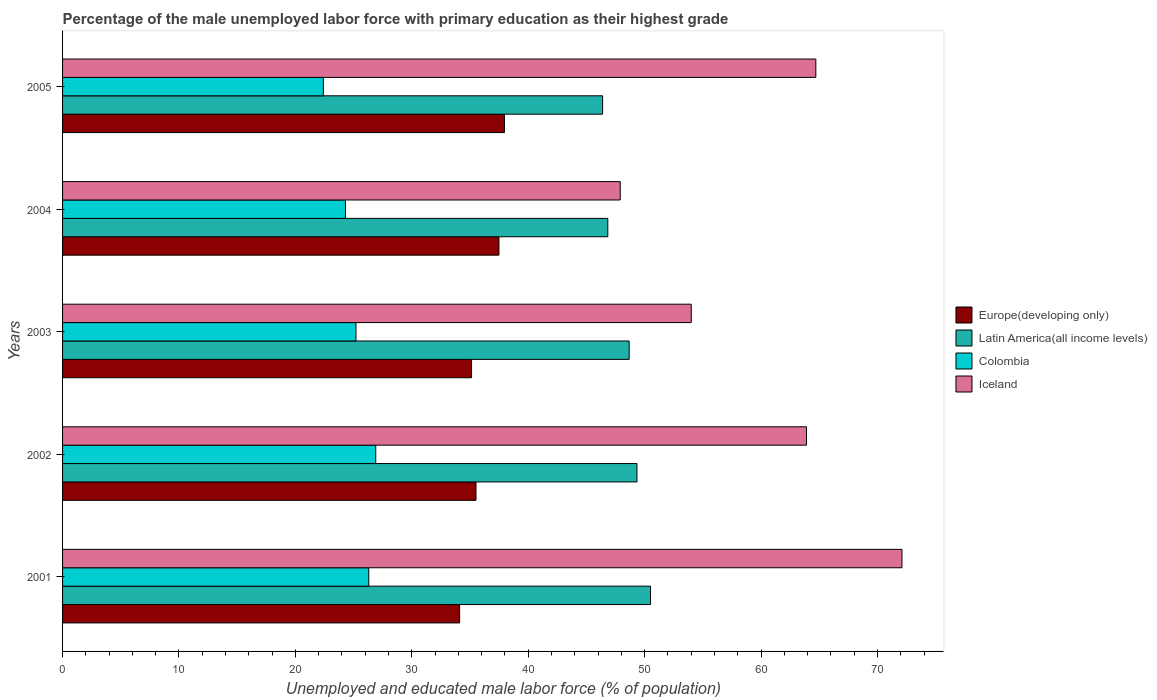Are the number of bars on each tick of the Y-axis equal?
Your response must be concise. Yes. How many bars are there on the 3rd tick from the bottom?
Provide a succinct answer. 4. What is the label of the 5th group of bars from the top?
Provide a short and direct response. 2001. What is the percentage of the unemployed male labor force with primary education in Iceland in 2002?
Ensure brevity in your answer.  63.9. Across all years, what is the maximum percentage of the unemployed male labor force with primary education in Latin America(all income levels)?
Your answer should be very brief. 50.5. Across all years, what is the minimum percentage of the unemployed male labor force with primary education in Latin America(all income levels)?
Offer a terse response. 46.39. In which year was the percentage of the unemployed male labor force with primary education in Colombia maximum?
Your answer should be very brief. 2002. In which year was the percentage of the unemployed male labor force with primary education in Iceland minimum?
Offer a very short reply. 2004. What is the total percentage of the unemployed male labor force with primary education in Iceland in the graph?
Make the answer very short. 302.6. What is the difference between the percentage of the unemployed male labor force with primary education in Iceland in 2001 and that in 2004?
Offer a very short reply. 24.2. What is the difference between the percentage of the unemployed male labor force with primary education in Latin America(all income levels) in 2003 and the percentage of the unemployed male labor force with primary education in Europe(developing only) in 2002?
Ensure brevity in your answer.  13.16. What is the average percentage of the unemployed male labor force with primary education in Colombia per year?
Offer a very short reply. 25.02. In the year 2001, what is the difference between the percentage of the unemployed male labor force with primary education in Latin America(all income levels) and percentage of the unemployed male labor force with primary education in Colombia?
Keep it short and to the point. 24.2. What is the ratio of the percentage of the unemployed male labor force with primary education in Colombia in 2002 to that in 2004?
Your answer should be very brief. 1.11. Is the difference between the percentage of the unemployed male labor force with primary education in Latin America(all income levels) in 2003 and 2005 greater than the difference between the percentage of the unemployed male labor force with primary education in Colombia in 2003 and 2005?
Your response must be concise. No. What is the difference between the highest and the second highest percentage of the unemployed male labor force with primary education in Iceland?
Provide a short and direct response. 7.4. What is the difference between the highest and the lowest percentage of the unemployed male labor force with primary education in Colombia?
Give a very brief answer. 4.5. In how many years, is the percentage of the unemployed male labor force with primary education in Iceland greater than the average percentage of the unemployed male labor force with primary education in Iceland taken over all years?
Make the answer very short. 3. What does the 2nd bar from the bottom in 2003 represents?
Provide a short and direct response. Latin America(all income levels). Is it the case that in every year, the sum of the percentage of the unemployed male labor force with primary education in Iceland and percentage of the unemployed male labor force with primary education in Colombia is greater than the percentage of the unemployed male labor force with primary education in Europe(developing only)?
Keep it short and to the point. Yes. Are the values on the major ticks of X-axis written in scientific E-notation?
Make the answer very short. No. Where does the legend appear in the graph?
Your response must be concise. Center right. How many legend labels are there?
Provide a short and direct response. 4. How are the legend labels stacked?
Make the answer very short. Vertical. What is the title of the graph?
Your answer should be compact. Percentage of the male unemployed labor force with primary education as their highest grade. What is the label or title of the X-axis?
Make the answer very short. Unemployed and educated male labor force (% of population). What is the Unemployed and educated male labor force (% of population) in Europe(developing only) in 2001?
Provide a short and direct response. 34.1. What is the Unemployed and educated male labor force (% of population) in Latin America(all income levels) in 2001?
Your answer should be very brief. 50.5. What is the Unemployed and educated male labor force (% of population) in Colombia in 2001?
Ensure brevity in your answer.  26.3. What is the Unemployed and educated male labor force (% of population) in Iceland in 2001?
Make the answer very short. 72.1. What is the Unemployed and educated male labor force (% of population) in Europe(developing only) in 2002?
Offer a terse response. 35.51. What is the Unemployed and educated male labor force (% of population) in Latin America(all income levels) in 2002?
Give a very brief answer. 49.34. What is the Unemployed and educated male labor force (% of population) in Colombia in 2002?
Provide a short and direct response. 26.9. What is the Unemployed and educated male labor force (% of population) in Iceland in 2002?
Make the answer very short. 63.9. What is the Unemployed and educated male labor force (% of population) in Europe(developing only) in 2003?
Ensure brevity in your answer.  35.13. What is the Unemployed and educated male labor force (% of population) in Latin America(all income levels) in 2003?
Offer a very short reply. 48.67. What is the Unemployed and educated male labor force (% of population) in Colombia in 2003?
Offer a terse response. 25.2. What is the Unemployed and educated male labor force (% of population) of Iceland in 2003?
Your answer should be very brief. 54. What is the Unemployed and educated male labor force (% of population) in Europe(developing only) in 2004?
Offer a terse response. 37.48. What is the Unemployed and educated male labor force (% of population) in Latin America(all income levels) in 2004?
Your response must be concise. 46.83. What is the Unemployed and educated male labor force (% of population) of Colombia in 2004?
Give a very brief answer. 24.3. What is the Unemployed and educated male labor force (% of population) in Iceland in 2004?
Offer a terse response. 47.9. What is the Unemployed and educated male labor force (% of population) in Europe(developing only) in 2005?
Your response must be concise. 37.96. What is the Unemployed and educated male labor force (% of population) of Latin America(all income levels) in 2005?
Ensure brevity in your answer.  46.39. What is the Unemployed and educated male labor force (% of population) in Colombia in 2005?
Ensure brevity in your answer.  22.4. What is the Unemployed and educated male labor force (% of population) in Iceland in 2005?
Give a very brief answer. 64.7. Across all years, what is the maximum Unemployed and educated male labor force (% of population) in Europe(developing only)?
Provide a succinct answer. 37.96. Across all years, what is the maximum Unemployed and educated male labor force (% of population) in Latin America(all income levels)?
Offer a very short reply. 50.5. Across all years, what is the maximum Unemployed and educated male labor force (% of population) of Colombia?
Provide a short and direct response. 26.9. Across all years, what is the maximum Unemployed and educated male labor force (% of population) of Iceland?
Keep it short and to the point. 72.1. Across all years, what is the minimum Unemployed and educated male labor force (% of population) in Europe(developing only)?
Offer a terse response. 34.1. Across all years, what is the minimum Unemployed and educated male labor force (% of population) in Latin America(all income levels)?
Ensure brevity in your answer.  46.39. Across all years, what is the minimum Unemployed and educated male labor force (% of population) of Colombia?
Offer a terse response. 22.4. Across all years, what is the minimum Unemployed and educated male labor force (% of population) of Iceland?
Make the answer very short. 47.9. What is the total Unemployed and educated male labor force (% of population) of Europe(developing only) in the graph?
Your answer should be compact. 180.18. What is the total Unemployed and educated male labor force (% of population) in Latin America(all income levels) in the graph?
Give a very brief answer. 241.73. What is the total Unemployed and educated male labor force (% of population) in Colombia in the graph?
Offer a terse response. 125.1. What is the total Unemployed and educated male labor force (% of population) in Iceland in the graph?
Keep it short and to the point. 302.6. What is the difference between the Unemployed and educated male labor force (% of population) in Europe(developing only) in 2001 and that in 2002?
Provide a succinct answer. -1.41. What is the difference between the Unemployed and educated male labor force (% of population) of Latin America(all income levels) in 2001 and that in 2002?
Your answer should be very brief. 1.16. What is the difference between the Unemployed and educated male labor force (% of population) of Colombia in 2001 and that in 2002?
Keep it short and to the point. -0.6. What is the difference between the Unemployed and educated male labor force (% of population) in Europe(developing only) in 2001 and that in 2003?
Your response must be concise. -1.03. What is the difference between the Unemployed and educated male labor force (% of population) of Latin America(all income levels) in 2001 and that in 2003?
Give a very brief answer. 1.83. What is the difference between the Unemployed and educated male labor force (% of population) of Colombia in 2001 and that in 2003?
Offer a terse response. 1.1. What is the difference between the Unemployed and educated male labor force (% of population) of Europe(developing only) in 2001 and that in 2004?
Provide a short and direct response. -3.38. What is the difference between the Unemployed and educated male labor force (% of population) in Latin America(all income levels) in 2001 and that in 2004?
Keep it short and to the point. 3.67. What is the difference between the Unemployed and educated male labor force (% of population) of Iceland in 2001 and that in 2004?
Give a very brief answer. 24.2. What is the difference between the Unemployed and educated male labor force (% of population) in Europe(developing only) in 2001 and that in 2005?
Give a very brief answer. -3.85. What is the difference between the Unemployed and educated male labor force (% of population) in Latin America(all income levels) in 2001 and that in 2005?
Keep it short and to the point. 4.12. What is the difference between the Unemployed and educated male labor force (% of population) in Iceland in 2001 and that in 2005?
Give a very brief answer. 7.4. What is the difference between the Unemployed and educated male labor force (% of population) of Europe(developing only) in 2002 and that in 2003?
Provide a succinct answer. 0.38. What is the difference between the Unemployed and educated male labor force (% of population) in Latin America(all income levels) in 2002 and that in 2003?
Make the answer very short. 0.67. What is the difference between the Unemployed and educated male labor force (% of population) in Iceland in 2002 and that in 2003?
Give a very brief answer. 9.9. What is the difference between the Unemployed and educated male labor force (% of population) of Europe(developing only) in 2002 and that in 2004?
Keep it short and to the point. -1.97. What is the difference between the Unemployed and educated male labor force (% of population) of Latin America(all income levels) in 2002 and that in 2004?
Provide a succinct answer. 2.51. What is the difference between the Unemployed and educated male labor force (% of population) of Europe(developing only) in 2002 and that in 2005?
Provide a short and direct response. -2.45. What is the difference between the Unemployed and educated male labor force (% of population) in Latin America(all income levels) in 2002 and that in 2005?
Your answer should be compact. 2.95. What is the difference between the Unemployed and educated male labor force (% of population) of Europe(developing only) in 2003 and that in 2004?
Provide a short and direct response. -2.35. What is the difference between the Unemployed and educated male labor force (% of population) in Latin America(all income levels) in 2003 and that in 2004?
Your answer should be very brief. 1.84. What is the difference between the Unemployed and educated male labor force (% of population) of Colombia in 2003 and that in 2004?
Your answer should be very brief. 0.9. What is the difference between the Unemployed and educated male labor force (% of population) in Iceland in 2003 and that in 2004?
Offer a terse response. 6.1. What is the difference between the Unemployed and educated male labor force (% of population) of Europe(developing only) in 2003 and that in 2005?
Your response must be concise. -2.83. What is the difference between the Unemployed and educated male labor force (% of population) of Latin America(all income levels) in 2003 and that in 2005?
Your answer should be compact. 2.28. What is the difference between the Unemployed and educated male labor force (% of population) of Colombia in 2003 and that in 2005?
Give a very brief answer. 2.8. What is the difference between the Unemployed and educated male labor force (% of population) of Europe(developing only) in 2004 and that in 2005?
Offer a very short reply. -0.47. What is the difference between the Unemployed and educated male labor force (% of population) in Latin America(all income levels) in 2004 and that in 2005?
Your answer should be compact. 0.45. What is the difference between the Unemployed and educated male labor force (% of population) of Iceland in 2004 and that in 2005?
Keep it short and to the point. -16.8. What is the difference between the Unemployed and educated male labor force (% of population) in Europe(developing only) in 2001 and the Unemployed and educated male labor force (% of population) in Latin America(all income levels) in 2002?
Keep it short and to the point. -15.23. What is the difference between the Unemployed and educated male labor force (% of population) in Europe(developing only) in 2001 and the Unemployed and educated male labor force (% of population) in Colombia in 2002?
Give a very brief answer. 7.2. What is the difference between the Unemployed and educated male labor force (% of population) of Europe(developing only) in 2001 and the Unemployed and educated male labor force (% of population) of Iceland in 2002?
Your response must be concise. -29.8. What is the difference between the Unemployed and educated male labor force (% of population) of Latin America(all income levels) in 2001 and the Unemployed and educated male labor force (% of population) of Colombia in 2002?
Provide a succinct answer. 23.6. What is the difference between the Unemployed and educated male labor force (% of population) of Latin America(all income levels) in 2001 and the Unemployed and educated male labor force (% of population) of Iceland in 2002?
Your response must be concise. -13.4. What is the difference between the Unemployed and educated male labor force (% of population) in Colombia in 2001 and the Unemployed and educated male labor force (% of population) in Iceland in 2002?
Your answer should be very brief. -37.6. What is the difference between the Unemployed and educated male labor force (% of population) in Europe(developing only) in 2001 and the Unemployed and educated male labor force (% of population) in Latin America(all income levels) in 2003?
Provide a succinct answer. -14.56. What is the difference between the Unemployed and educated male labor force (% of population) in Europe(developing only) in 2001 and the Unemployed and educated male labor force (% of population) in Colombia in 2003?
Provide a short and direct response. 8.9. What is the difference between the Unemployed and educated male labor force (% of population) of Europe(developing only) in 2001 and the Unemployed and educated male labor force (% of population) of Iceland in 2003?
Keep it short and to the point. -19.9. What is the difference between the Unemployed and educated male labor force (% of population) in Latin America(all income levels) in 2001 and the Unemployed and educated male labor force (% of population) in Colombia in 2003?
Provide a succinct answer. 25.3. What is the difference between the Unemployed and educated male labor force (% of population) in Latin America(all income levels) in 2001 and the Unemployed and educated male labor force (% of population) in Iceland in 2003?
Give a very brief answer. -3.5. What is the difference between the Unemployed and educated male labor force (% of population) of Colombia in 2001 and the Unemployed and educated male labor force (% of population) of Iceland in 2003?
Ensure brevity in your answer.  -27.7. What is the difference between the Unemployed and educated male labor force (% of population) in Europe(developing only) in 2001 and the Unemployed and educated male labor force (% of population) in Latin America(all income levels) in 2004?
Ensure brevity in your answer.  -12.73. What is the difference between the Unemployed and educated male labor force (% of population) in Europe(developing only) in 2001 and the Unemployed and educated male labor force (% of population) in Colombia in 2004?
Offer a terse response. 9.8. What is the difference between the Unemployed and educated male labor force (% of population) in Europe(developing only) in 2001 and the Unemployed and educated male labor force (% of population) in Iceland in 2004?
Provide a short and direct response. -13.8. What is the difference between the Unemployed and educated male labor force (% of population) of Latin America(all income levels) in 2001 and the Unemployed and educated male labor force (% of population) of Colombia in 2004?
Your response must be concise. 26.2. What is the difference between the Unemployed and educated male labor force (% of population) in Latin America(all income levels) in 2001 and the Unemployed and educated male labor force (% of population) in Iceland in 2004?
Provide a short and direct response. 2.6. What is the difference between the Unemployed and educated male labor force (% of population) in Colombia in 2001 and the Unemployed and educated male labor force (% of population) in Iceland in 2004?
Your answer should be compact. -21.6. What is the difference between the Unemployed and educated male labor force (% of population) of Europe(developing only) in 2001 and the Unemployed and educated male labor force (% of population) of Latin America(all income levels) in 2005?
Keep it short and to the point. -12.28. What is the difference between the Unemployed and educated male labor force (% of population) in Europe(developing only) in 2001 and the Unemployed and educated male labor force (% of population) in Colombia in 2005?
Keep it short and to the point. 11.7. What is the difference between the Unemployed and educated male labor force (% of population) in Europe(developing only) in 2001 and the Unemployed and educated male labor force (% of population) in Iceland in 2005?
Your answer should be compact. -30.6. What is the difference between the Unemployed and educated male labor force (% of population) in Latin America(all income levels) in 2001 and the Unemployed and educated male labor force (% of population) in Colombia in 2005?
Your answer should be compact. 28.1. What is the difference between the Unemployed and educated male labor force (% of population) in Latin America(all income levels) in 2001 and the Unemployed and educated male labor force (% of population) in Iceland in 2005?
Ensure brevity in your answer.  -14.2. What is the difference between the Unemployed and educated male labor force (% of population) in Colombia in 2001 and the Unemployed and educated male labor force (% of population) in Iceland in 2005?
Keep it short and to the point. -38.4. What is the difference between the Unemployed and educated male labor force (% of population) of Europe(developing only) in 2002 and the Unemployed and educated male labor force (% of population) of Latin America(all income levels) in 2003?
Keep it short and to the point. -13.16. What is the difference between the Unemployed and educated male labor force (% of population) in Europe(developing only) in 2002 and the Unemployed and educated male labor force (% of population) in Colombia in 2003?
Make the answer very short. 10.31. What is the difference between the Unemployed and educated male labor force (% of population) in Europe(developing only) in 2002 and the Unemployed and educated male labor force (% of population) in Iceland in 2003?
Give a very brief answer. -18.49. What is the difference between the Unemployed and educated male labor force (% of population) of Latin America(all income levels) in 2002 and the Unemployed and educated male labor force (% of population) of Colombia in 2003?
Ensure brevity in your answer.  24.14. What is the difference between the Unemployed and educated male labor force (% of population) of Latin America(all income levels) in 2002 and the Unemployed and educated male labor force (% of population) of Iceland in 2003?
Offer a very short reply. -4.66. What is the difference between the Unemployed and educated male labor force (% of population) in Colombia in 2002 and the Unemployed and educated male labor force (% of population) in Iceland in 2003?
Give a very brief answer. -27.1. What is the difference between the Unemployed and educated male labor force (% of population) in Europe(developing only) in 2002 and the Unemployed and educated male labor force (% of population) in Latin America(all income levels) in 2004?
Your answer should be compact. -11.32. What is the difference between the Unemployed and educated male labor force (% of population) in Europe(developing only) in 2002 and the Unemployed and educated male labor force (% of population) in Colombia in 2004?
Provide a succinct answer. 11.21. What is the difference between the Unemployed and educated male labor force (% of population) of Europe(developing only) in 2002 and the Unemployed and educated male labor force (% of population) of Iceland in 2004?
Keep it short and to the point. -12.39. What is the difference between the Unemployed and educated male labor force (% of population) of Latin America(all income levels) in 2002 and the Unemployed and educated male labor force (% of population) of Colombia in 2004?
Provide a succinct answer. 25.04. What is the difference between the Unemployed and educated male labor force (% of population) in Latin America(all income levels) in 2002 and the Unemployed and educated male labor force (% of population) in Iceland in 2004?
Provide a succinct answer. 1.44. What is the difference between the Unemployed and educated male labor force (% of population) in Europe(developing only) in 2002 and the Unemployed and educated male labor force (% of population) in Latin America(all income levels) in 2005?
Provide a succinct answer. -10.88. What is the difference between the Unemployed and educated male labor force (% of population) in Europe(developing only) in 2002 and the Unemployed and educated male labor force (% of population) in Colombia in 2005?
Offer a very short reply. 13.11. What is the difference between the Unemployed and educated male labor force (% of population) in Europe(developing only) in 2002 and the Unemployed and educated male labor force (% of population) in Iceland in 2005?
Make the answer very short. -29.19. What is the difference between the Unemployed and educated male labor force (% of population) of Latin America(all income levels) in 2002 and the Unemployed and educated male labor force (% of population) of Colombia in 2005?
Provide a short and direct response. 26.94. What is the difference between the Unemployed and educated male labor force (% of population) in Latin America(all income levels) in 2002 and the Unemployed and educated male labor force (% of population) in Iceland in 2005?
Offer a terse response. -15.36. What is the difference between the Unemployed and educated male labor force (% of population) of Colombia in 2002 and the Unemployed and educated male labor force (% of population) of Iceland in 2005?
Give a very brief answer. -37.8. What is the difference between the Unemployed and educated male labor force (% of population) in Europe(developing only) in 2003 and the Unemployed and educated male labor force (% of population) in Latin America(all income levels) in 2004?
Offer a terse response. -11.7. What is the difference between the Unemployed and educated male labor force (% of population) in Europe(developing only) in 2003 and the Unemployed and educated male labor force (% of population) in Colombia in 2004?
Your answer should be compact. 10.83. What is the difference between the Unemployed and educated male labor force (% of population) in Europe(developing only) in 2003 and the Unemployed and educated male labor force (% of population) in Iceland in 2004?
Offer a terse response. -12.77. What is the difference between the Unemployed and educated male labor force (% of population) in Latin America(all income levels) in 2003 and the Unemployed and educated male labor force (% of population) in Colombia in 2004?
Your answer should be compact. 24.37. What is the difference between the Unemployed and educated male labor force (% of population) of Latin America(all income levels) in 2003 and the Unemployed and educated male labor force (% of population) of Iceland in 2004?
Ensure brevity in your answer.  0.77. What is the difference between the Unemployed and educated male labor force (% of population) in Colombia in 2003 and the Unemployed and educated male labor force (% of population) in Iceland in 2004?
Keep it short and to the point. -22.7. What is the difference between the Unemployed and educated male labor force (% of population) of Europe(developing only) in 2003 and the Unemployed and educated male labor force (% of population) of Latin America(all income levels) in 2005?
Provide a short and direct response. -11.26. What is the difference between the Unemployed and educated male labor force (% of population) in Europe(developing only) in 2003 and the Unemployed and educated male labor force (% of population) in Colombia in 2005?
Make the answer very short. 12.73. What is the difference between the Unemployed and educated male labor force (% of population) of Europe(developing only) in 2003 and the Unemployed and educated male labor force (% of population) of Iceland in 2005?
Keep it short and to the point. -29.57. What is the difference between the Unemployed and educated male labor force (% of population) of Latin America(all income levels) in 2003 and the Unemployed and educated male labor force (% of population) of Colombia in 2005?
Give a very brief answer. 26.27. What is the difference between the Unemployed and educated male labor force (% of population) of Latin America(all income levels) in 2003 and the Unemployed and educated male labor force (% of population) of Iceland in 2005?
Offer a very short reply. -16.03. What is the difference between the Unemployed and educated male labor force (% of population) in Colombia in 2003 and the Unemployed and educated male labor force (% of population) in Iceland in 2005?
Your answer should be compact. -39.5. What is the difference between the Unemployed and educated male labor force (% of population) of Europe(developing only) in 2004 and the Unemployed and educated male labor force (% of population) of Latin America(all income levels) in 2005?
Make the answer very short. -8.91. What is the difference between the Unemployed and educated male labor force (% of population) of Europe(developing only) in 2004 and the Unemployed and educated male labor force (% of population) of Colombia in 2005?
Give a very brief answer. 15.08. What is the difference between the Unemployed and educated male labor force (% of population) in Europe(developing only) in 2004 and the Unemployed and educated male labor force (% of population) in Iceland in 2005?
Provide a succinct answer. -27.22. What is the difference between the Unemployed and educated male labor force (% of population) of Latin America(all income levels) in 2004 and the Unemployed and educated male labor force (% of population) of Colombia in 2005?
Give a very brief answer. 24.43. What is the difference between the Unemployed and educated male labor force (% of population) of Latin America(all income levels) in 2004 and the Unemployed and educated male labor force (% of population) of Iceland in 2005?
Give a very brief answer. -17.87. What is the difference between the Unemployed and educated male labor force (% of population) in Colombia in 2004 and the Unemployed and educated male labor force (% of population) in Iceland in 2005?
Make the answer very short. -40.4. What is the average Unemployed and educated male labor force (% of population) of Europe(developing only) per year?
Your response must be concise. 36.04. What is the average Unemployed and educated male labor force (% of population) in Latin America(all income levels) per year?
Provide a short and direct response. 48.35. What is the average Unemployed and educated male labor force (% of population) in Colombia per year?
Provide a succinct answer. 25.02. What is the average Unemployed and educated male labor force (% of population) in Iceland per year?
Provide a short and direct response. 60.52. In the year 2001, what is the difference between the Unemployed and educated male labor force (% of population) of Europe(developing only) and Unemployed and educated male labor force (% of population) of Latin America(all income levels)?
Give a very brief answer. -16.4. In the year 2001, what is the difference between the Unemployed and educated male labor force (% of population) in Europe(developing only) and Unemployed and educated male labor force (% of population) in Colombia?
Provide a succinct answer. 7.8. In the year 2001, what is the difference between the Unemployed and educated male labor force (% of population) in Europe(developing only) and Unemployed and educated male labor force (% of population) in Iceland?
Your answer should be very brief. -38. In the year 2001, what is the difference between the Unemployed and educated male labor force (% of population) of Latin America(all income levels) and Unemployed and educated male labor force (% of population) of Colombia?
Offer a very short reply. 24.2. In the year 2001, what is the difference between the Unemployed and educated male labor force (% of population) in Latin America(all income levels) and Unemployed and educated male labor force (% of population) in Iceland?
Make the answer very short. -21.6. In the year 2001, what is the difference between the Unemployed and educated male labor force (% of population) in Colombia and Unemployed and educated male labor force (% of population) in Iceland?
Your answer should be compact. -45.8. In the year 2002, what is the difference between the Unemployed and educated male labor force (% of population) in Europe(developing only) and Unemployed and educated male labor force (% of population) in Latin America(all income levels)?
Make the answer very short. -13.83. In the year 2002, what is the difference between the Unemployed and educated male labor force (% of population) in Europe(developing only) and Unemployed and educated male labor force (% of population) in Colombia?
Your response must be concise. 8.61. In the year 2002, what is the difference between the Unemployed and educated male labor force (% of population) of Europe(developing only) and Unemployed and educated male labor force (% of population) of Iceland?
Offer a very short reply. -28.39. In the year 2002, what is the difference between the Unemployed and educated male labor force (% of population) in Latin America(all income levels) and Unemployed and educated male labor force (% of population) in Colombia?
Provide a succinct answer. 22.44. In the year 2002, what is the difference between the Unemployed and educated male labor force (% of population) in Latin America(all income levels) and Unemployed and educated male labor force (% of population) in Iceland?
Offer a terse response. -14.56. In the year 2002, what is the difference between the Unemployed and educated male labor force (% of population) in Colombia and Unemployed and educated male labor force (% of population) in Iceland?
Offer a terse response. -37. In the year 2003, what is the difference between the Unemployed and educated male labor force (% of population) in Europe(developing only) and Unemployed and educated male labor force (% of population) in Latin America(all income levels)?
Offer a very short reply. -13.54. In the year 2003, what is the difference between the Unemployed and educated male labor force (% of population) in Europe(developing only) and Unemployed and educated male labor force (% of population) in Colombia?
Give a very brief answer. 9.93. In the year 2003, what is the difference between the Unemployed and educated male labor force (% of population) in Europe(developing only) and Unemployed and educated male labor force (% of population) in Iceland?
Ensure brevity in your answer.  -18.87. In the year 2003, what is the difference between the Unemployed and educated male labor force (% of population) in Latin America(all income levels) and Unemployed and educated male labor force (% of population) in Colombia?
Offer a terse response. 23.47. In the year 2003, what is the difference between the Unemployed and educated male labor force (% of population) of Latin America(all income levels) and Unemployed and educated male labor force (% of population) of Iceland?
Provide a short and direct response. -5.33. In the year 2003, what is the difference between the Unemployed and educated male labor force (% of population) in Colombia and Unemployed and educated male labor force (% of population) in Iceland?
Keep it short and to the point. -28.8. In the year 2004, what is the difference between the Unemployed and educated male labor force (% of population) of Europe(developing only) and Unemployed and educated male labor force (% of population) of Latin America(all income levels)?
Provide a short and direct response. -9.35. In the year 2004, what is the difference between the Unemployed and educated male labor force (% of population) in Europe(developing only) and Unemployed and educated male labor force (% of population) in Colombia?
Your answer should be compact. 13.18. In the year 2004, what is the difference between the Unemployed and educated male labor force (% of population) of Europe(developing only) and Unemployed and educated male labor force (% of population) of Iceland?
Your answer should be very brief. -10.42. In the year 2004, what is the difference between the Unemployed and educated male labor force (% of population) of Latin America(all income levels) and Unemployed and educated male labor force (% of population) of Colombia?
Your answer should be compact. 22.53. In the year 2004, what is the difference between the Unemployed and educated male labor force (% of population) in Latin America(all income levels) and Unemployed and educated male labor force (% of population) in Iceland?
Offer a very short reply. -1.07. In the year 2004, what is the difference between the Unemployed and educated male labor force (% of population) of Colombia and Unemployed and educated male labor force (% of population) of Iceland?
Your answer should be very brief. -23.6. In the year 2005, what is the difference between the Unemployed and educated male labor force (% of population) of Europe(developing only) and Unemployed and educated male labor force (% of population) of Latin America(all income levels)?
Your answer should be very brief. -8.43. In the year 2005, what is the difference between the Unemployed and educated male labor force (% of population) in Europe(developing only) and Unemployed and educated male labor force (% of population) in Colombia?
Make the answer very short. 15.56. In the year 2005, what is the difference between the Unemployed and educated male labor force (% of population) in Europe(developing only) and Unemployed and educated male labor force (% of population) in Iceland?
Give a very brief answer. -26.74. In the year 2005, what is the difference between the Unemployed and educated male labor force (% of population) in Latin America(all income levels) and Unemployed and educated male labor force (% of population) in Colombia?
Ensure brevity in your answer.  23.99. In the year 2005, what is the difference between the Unemployed and educated male labor force (% of population) in Latin America(all income levels) and Unemployed and educated male labor force (% of population) in Iceland?
Your answer should be compact. -18.31. In the year 2005, what is the difference between the Unemployed and educated male labor force (% of population) in Colombia and Unemployed and educated male labor force (% of population) in Iceland?
Give a very brief answer. -42.3. What is the ratio of the Unemployed and educated male labor force (% of population) of Europe(developing only) in 2001 to that in 2002?
Your answer should be compact. 0.96. What is the ratio of the Unemployed and educated male labor force (% of population) in Latin America(all income levels) in 2001 to that in 2002?
Keep it short and to the point. 1.02. What is the ratio of the Unemployed and educated male labor force (% of population) of Colombia in 2001 to that in 2002?
Keep it short and to the point. 0.98. What is the ratio of the Unemployed and educated male labor force (% of population) in Iceland in 2001 to that in 2002?
Keep it short and to the point. 1.13. What is the ratio of the Unemployed and educated male labor force (% of population) in Europe(developing only) in 2001 to that in 2003?
Make the answer very short. 0.97. What is the ratio of the Unemployed and educated male labor force (% of population) of Latin America(all income levels) in 2001 to that in 2003?
Provide a short and direct response. 1.04. What is the ratio of the Unemployed and educated male labor force (% of population) of Colombia in 2001 to that in 2003?
Your response must be concise. 1.04. What is the ratio of the Unemployed and educated male labor force (% of population) in Iceland in 2001 to that in 2003?
Provide a succinct answer. 1.34. What is the ratio of the Unemployed and educated male labor force (% of population) in Europe(developing only) in 2001 to that in 2004?
Your response must be concise. 0.91. What is the ratio of the Unemployed and educated male labor force (% of population) in Latin America(all income levels) in 2001 to that in 2004?
Keep it short and to the point. 1.08. What is the ratio of the Unemployed and educated male labor force (% of population) of Colombia in 2001 to that in 2004?
Provide a succinct answer. 1.08. What is the ratio of the Unemployed and educated male labor force (% of population) in Iceland in 2001 to that in 2004?
Provide a succinct answer. 1.51. What is the ratio of the Unemployed and educated male labor force (% of population) in Europe(developing only) in 2001 to that in 2005?
Give a very brief answer. 0.9. What is the ratio of the Unemployed and educated male labor force (% of population) in Latin America(all income levels) in 2001 to that in 2005?
Ensure brevity in your answer.  1.09. What is the ratio of the Unemployed and educated male labor force (% of population) of Colombia in 2001 to that in 2005?
Ensure brevity in your answer.  1.17. What is the ratio of the Unemployed and educated male labor force (% of population) in Iceland in 2001 to that in 2005?
Provide a short and direct response. 1.11. What is the ratio of the Unemployed and educated male labor force (% of population) in Europe(developing only) in 2002 to that in 2003?
Keep it short and to the point. 1.01. What is the ratio of the Unemployed and educated male labor force (% of population) in Latin America(all income levels) in 2002 to that in 2003?
Keep it short and to the point. 1.01. What is the ratio of the Unemployed and educated male labor force (% of population) of Colombia in 2002 to that in 2003?
Offer a terse response. 1.07. What is the ratio of the Unemployed and educated male labor force (% of population) in Iceland in 2002 to that in 2003?
Keep it short and to the point. 1.18. What is the ratio of the Unemployed and educated male labor force (% of population) of Latin America(all income levels) in 2002 to that in 2004?
Ensure brevity in your answer.  1.05. What is the ratio of the Unemployed and educated male labor force (% of population) in Colombia in 2002 to that in 2004?
Your response must be concise. 1.11. What is the ratio of the Unemployed and educated male labor force (% of population) of Iceland in 2002 to that in 2004?
Provide a succinct answer. 1.33. What is the ratio of the Unemployed and educated male labor force (% of population) in Europe(developing only) in 2002 to that in 2005?
Ensure brevity in your answer.  0.94. What is the ratio of the Unemployed and educated male labor force (% of population) in Latin America(all income levels) in 2002 to that in 2005?
Make the answer very short. 1.06. What is the ratio of the Unemployed and educated male labor force (% of population) in Colombia in 2002 to that in 2005?
Your response must be concise. 1.2. What is the ratio of the Unemployed and educated male labor force (% of population) of Iceland in 2002 to that in 2005?
Make the answer very short. 0.99. What is the ratio of the Unemployed and educated male labor force (% of population) in Europe(developing only) in 2003 to that in 2004?
Your response must be concise. 0.94. What is the ratio of the Unemployed and educated male labor force (% of population) in Latin America(all income levels) in 2003 to that in 2004?
Provide a short and direct response. 1.04. What is the ratio of the Unemployed and educated male labor force (% of population) in Colombia in 2003 to that in 2004?
Make the answer very short. 1.04. What is the ratio of the Unemployed and educated male labor force (% of population) in Iceland in 2003 to that in 2004?
Your answer should be compact. 1.13. What is the ratio of the Unemployed and educated male labor force (% of population) of Europe(developing only) in 2003 to that in 2005?
Provide a short and direct response. 0.93. What is the ratio of the Unemployed and educated male labor force (% of population) of Latin America(all income levels) in 2003 to that in 2005?
Your answer should be very brief. 1.05. What is the ratio of the Unemployed and educated male labor force (% of population) of Iceland in 2003 to that in 2005?
Offer a terse response. 0.83. What is the ratio of the Unemployed and educated male labor force (% of population) of Europe(developing only) in 2004 to that in 2005?
Provide a succinct answer. 0.99. What is the ratio of the Unemployed and educated male labor force (% of population) in Latin America(all income levels) in 2004 to that in 2005?
Ensure brevity in your answer.  1.01. What is the ratio of the Unemployed and educated male labor force (% of population) of Colombia in 2004 to that in 2005?
Provide a short and direct response. 1.08. What is the ratio of the Unemployed and educated male labor force (% of population) in Iceland in 2004 to that in 2005?
Keep it short and to the point. 0.74. What is the difference between the highest and the second highest Unemployed and educated male labor force (% of population) of Europe(developing only)?
Your answer should be very brief. 0.47. What is the difference between the highest and the second highest Unemployed and educated male labor force (% of population) of Latin America(all income levels)?
Make the answer very short. 1.16. What is the difference between the highest and the second highest Unemployed and educated male labor force (% of population) of Colombia?
Offer a terse response. 0.6. What is the difference between the highest and the lowest Unemployed and educated male labor force (% of population) of Europe(developing only)?
Keep it short and to the point. 3.85. What is the difference between the highest and the lowest Unemployed and educated male labor force (% of population) in Latin America(all income levels)?
Provide a succinct answer. 4.12. What is the difference between the highest and the lowest Unemployed and educated male labor force (% of population) of Iceland?
Your answer should be compact. 24.2. 